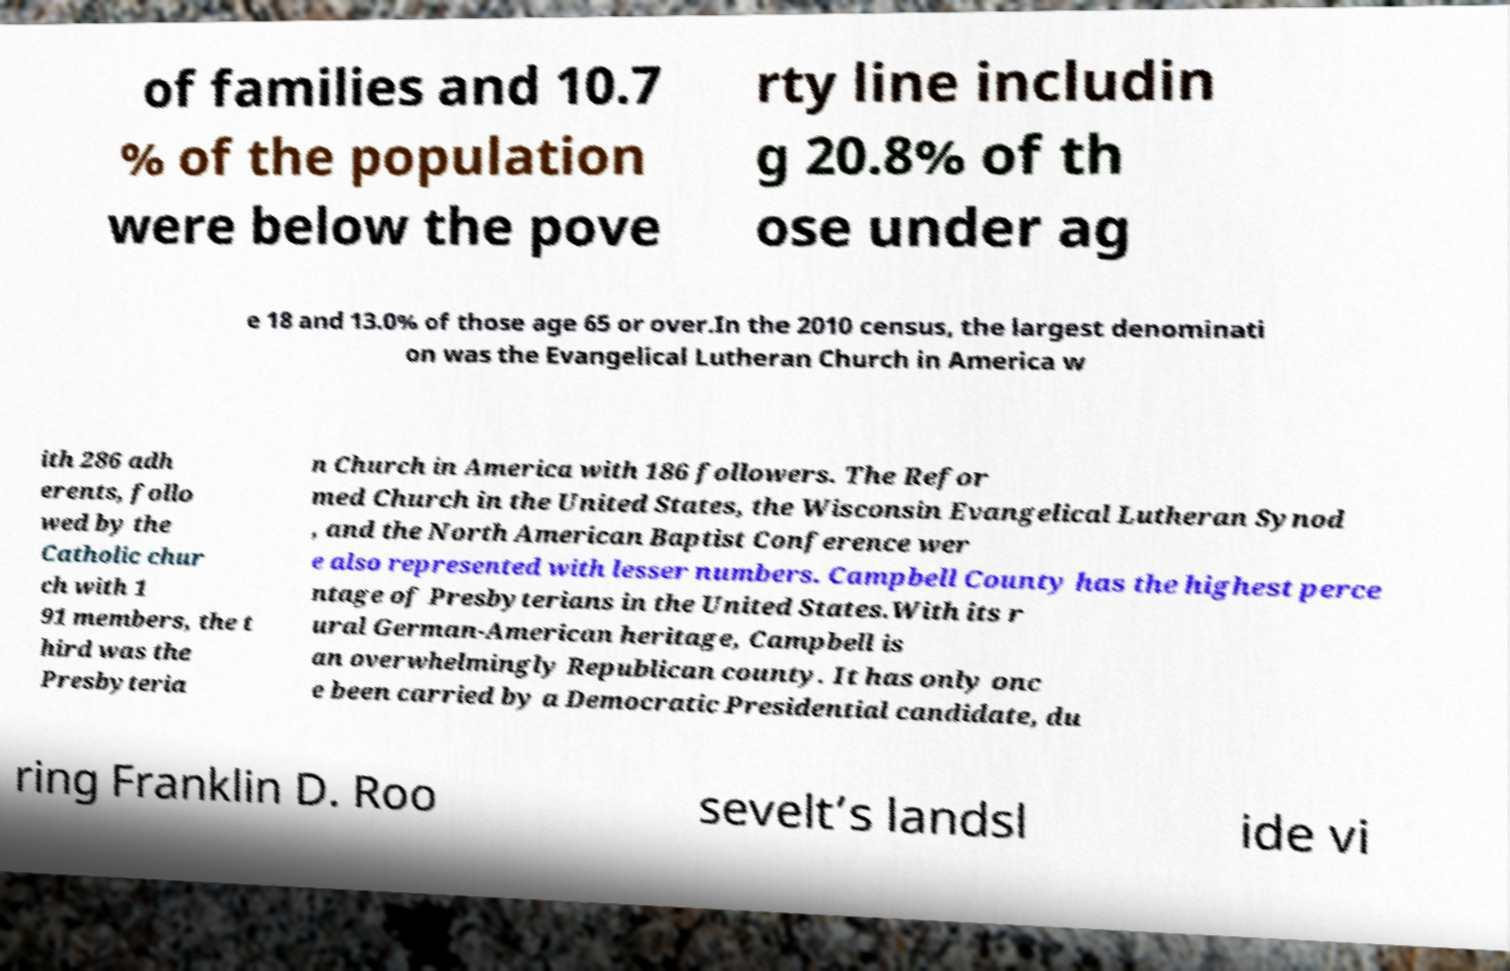There's text embedded in this image that I need extracted. Can you transcribe it verbatim? of families and 10.7 % of the population were below the pove rty line includin g 20.8% of th ose under ag e 18 and 13.0% of those age 65 or over.In the 2010 census, the largest denominati on was the Evangelical Lutheran Church in America w ith 286 adh erents, follo wed by the Catholic chur ch with 1 91 members, the t hird was the Presbyteria n Church in America with 186 followers. The Refor med Church in the United States, the Wisconsin Evangelical Lutheran Synod , and the North American Baptist Conference wer e also represented with lesser numbers. Campbell County has the highest perce ntage of Presbyterians in the United States.With its r ural German-American heritage, Campbell is an overwhelmingly Republican county. It has only onc e been carried by a Democratic Presidential candidate, du ring Franklin D. Roo sevelt’s landsl ide vi 